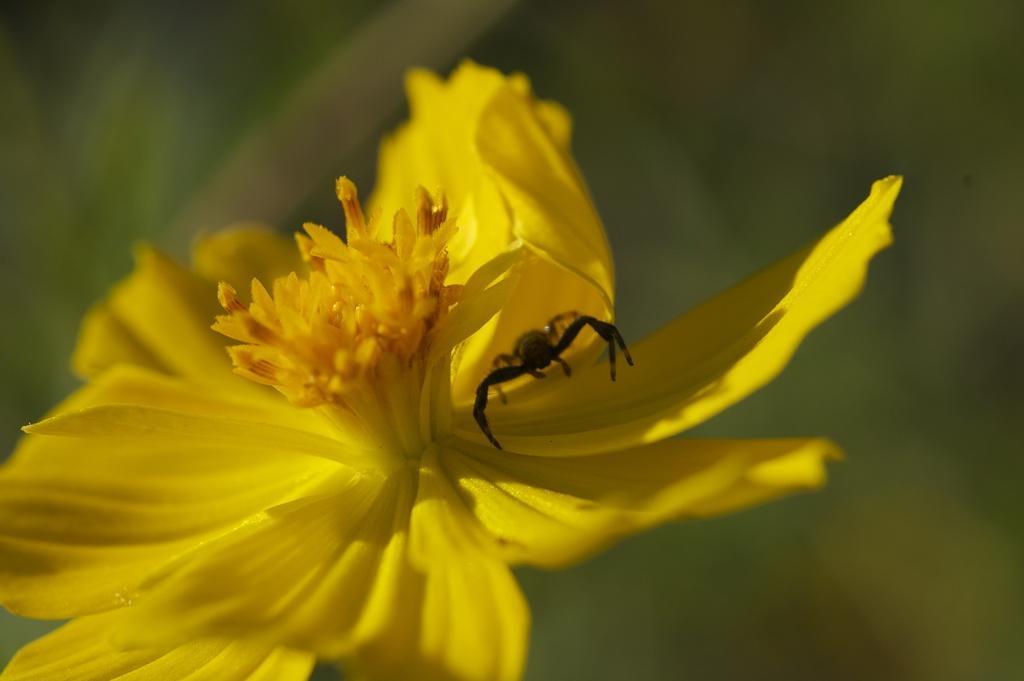Describe this image in one or two sentences. In this image I can see a beautiful flower and there is an insect on it. 